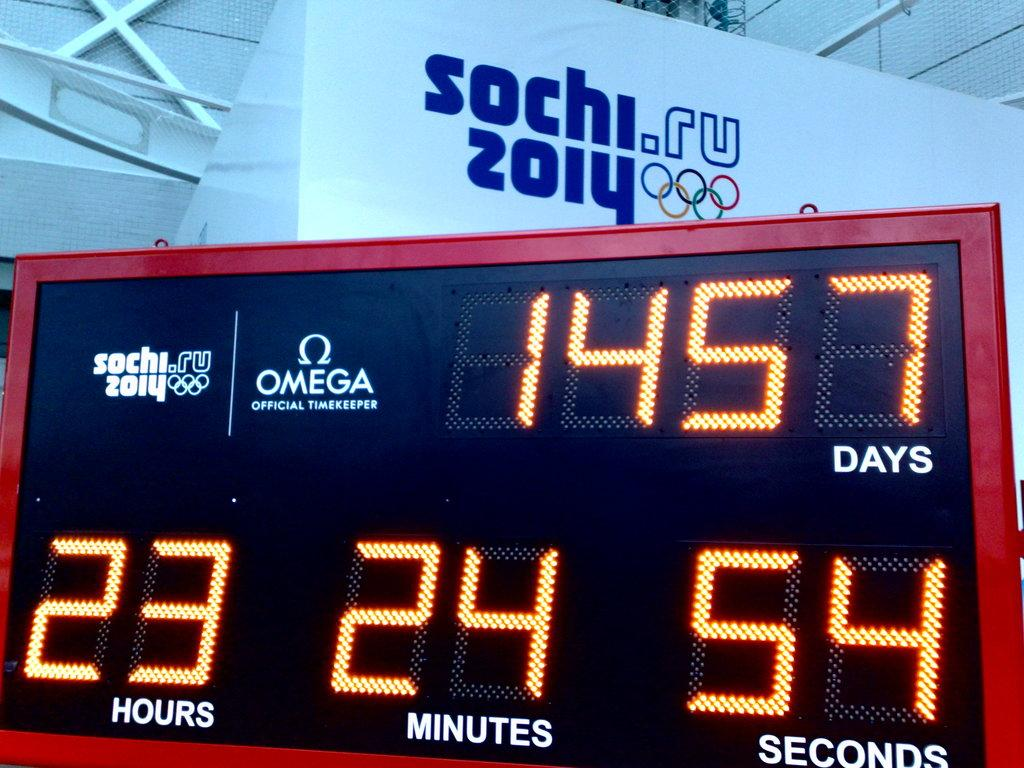<image>
Summarize the visual content of the image. A clock readout at the Sochi Russian olympics displays 1457 DAYS. 